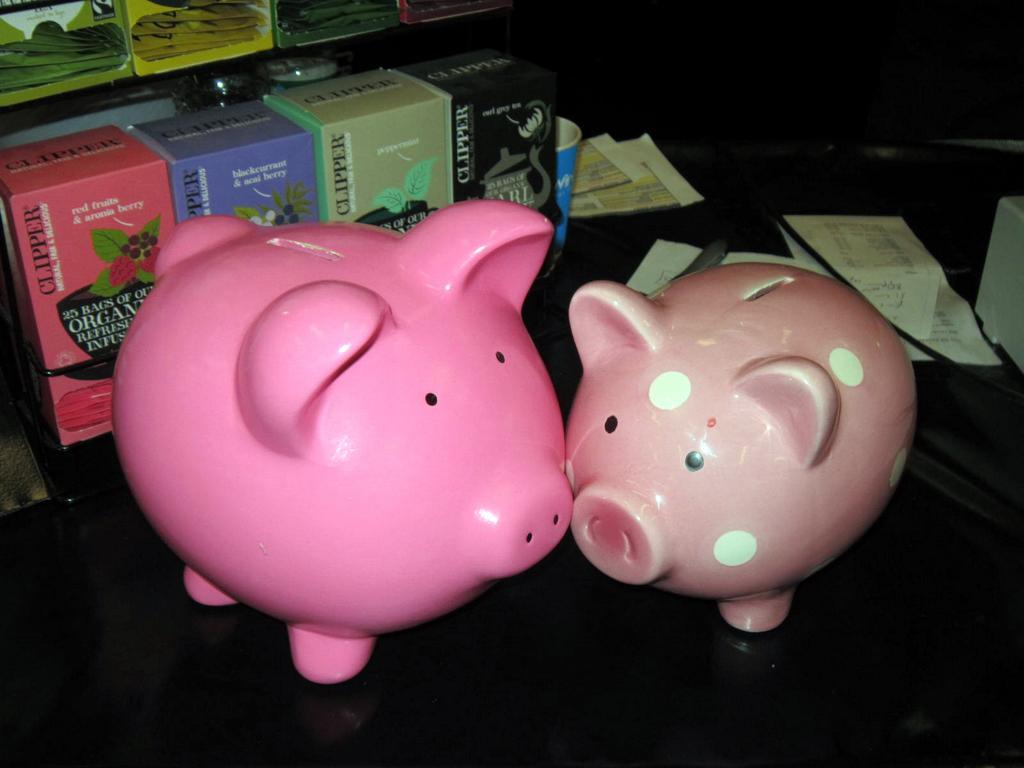Could you give a brief overview of what you see in this image? In this image we can see two piggy banks, group of boxes, papers are placed on the surface. In the background, we can see some boxes containing packets on the rack. 